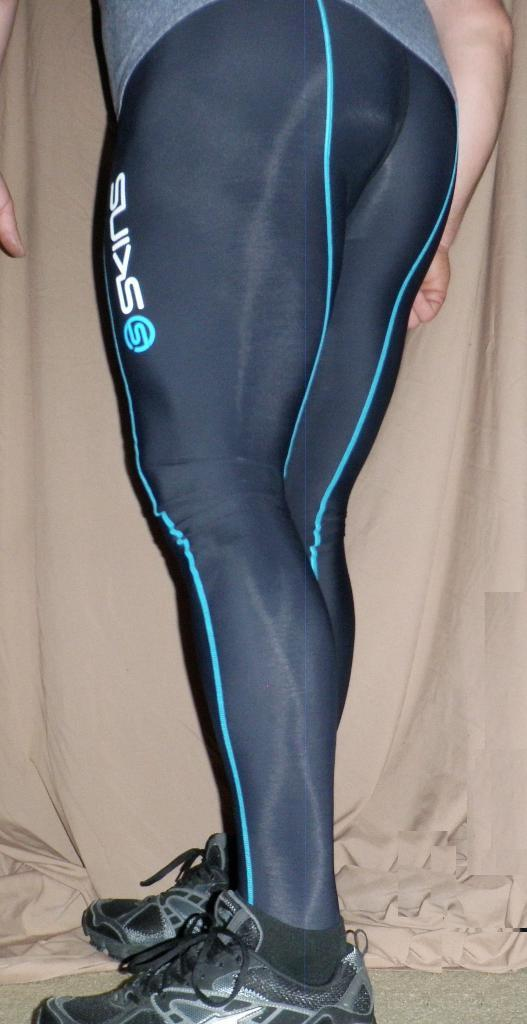Who or what is present in the image? There is a person in the image. What type of footwear is the person wearing? The person is wearing shoes. Can you describe anything in the background of the image? There is a cloth visible in the background of the image. What is the hen's belief about the person in the image? There is no hen present in the image, so it is not possible to determine its beliefs about the person. 